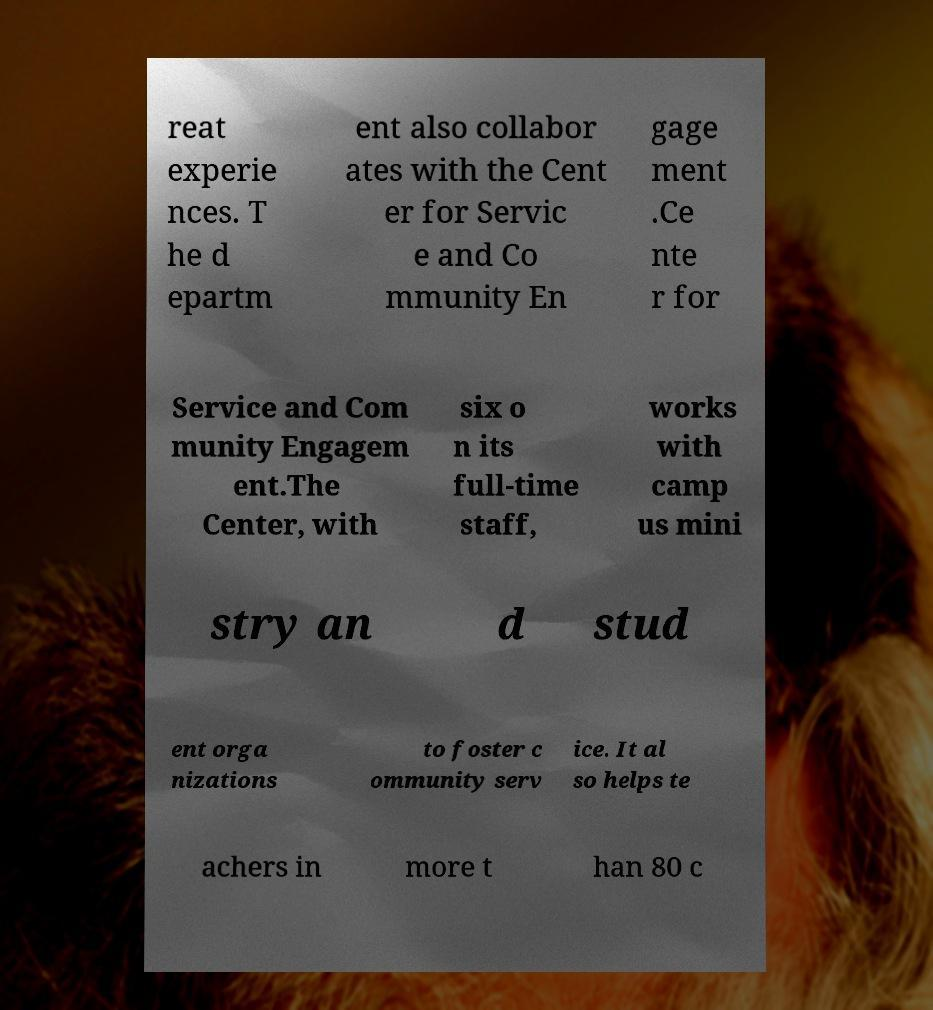What messages or text are displayed in this image? I need them in a readable, typed format. reat experie nces. T he d epartm ent also collabor ates with the Cent er for Servic e and Co mmunity En gage ment .Ce nte r for Service and Com munity Engagem ent.The Center, with six o n its full-time staff, works with camp us mini stry an d stud ent orga nizations to foster c ommunity serv ice. It al so helps te achers in more t han 80 c 